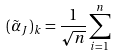<formula> <loc_0><loc_0><loc_500><loc_500>( \tilde { \alpha } _ { J } ) _ { k } = \frac { 1 } { \sqrt { n } } \sum _ { i = 1 } ^ { n }</formula> 